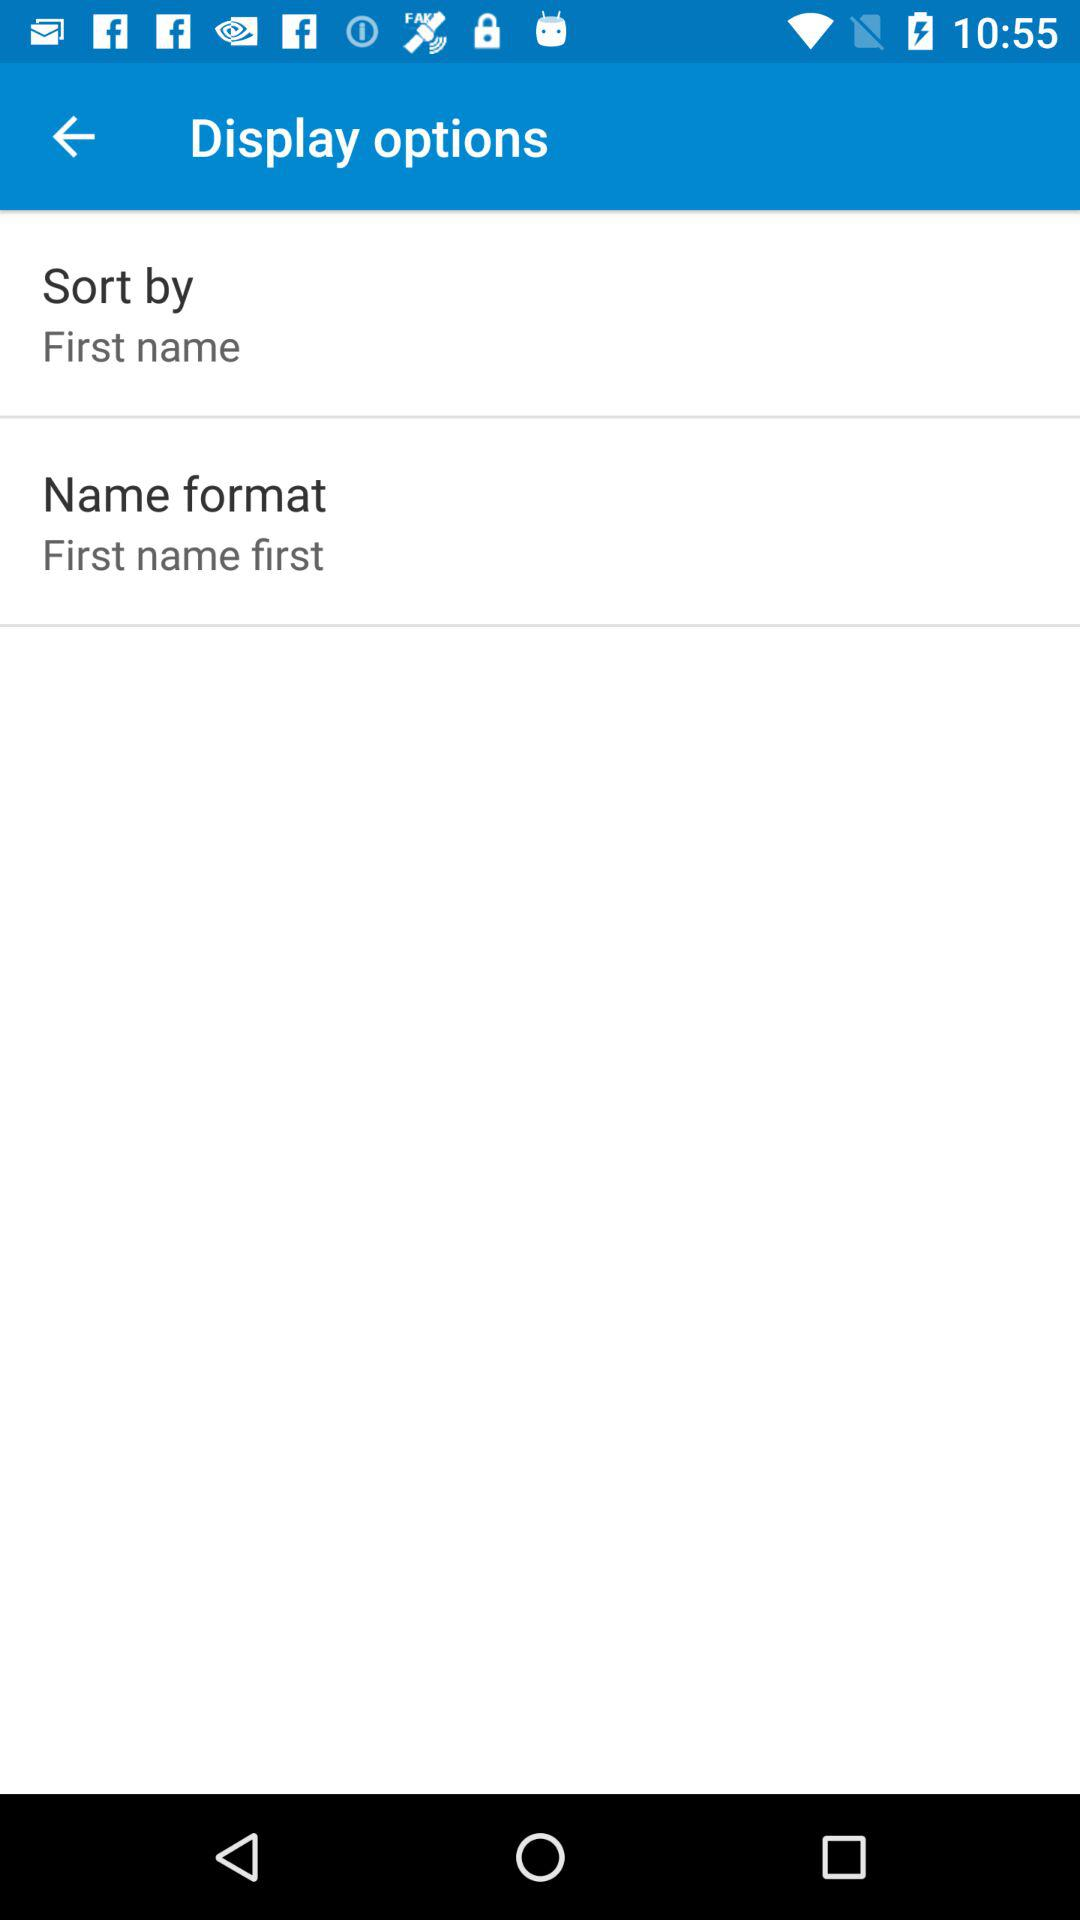Which option is selected in "Sort by"? The selected option in "Sort by" is "First name". 